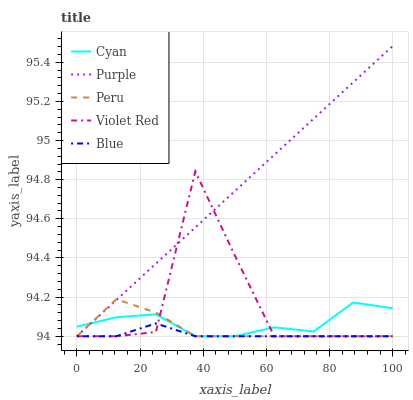Does Blue have the minimum area under the curve?
Answer yes or no. Yes. Does Purple have the maximum area under the curve?
Answer yes or no. Yes. Does Cyan have the minimum area under the curve?
Answer yes or no. No. Does Cyan have the maximum area under the curve?
Answer yes or no. No. Is Purple the smoothest?
Answer yes or no. Yes. Is Violet Red the roughest?
Answer yes or no. Yes. Is Cyan the smoothest?
Answer yes or no. No. Is Cyan the roughest?
Answer yes or no. No. Does Purple have the lowest value?
Answer yes or no. Yes. Does Purple have the highest value?
Answer yes or no. Yes. Does Cyan have the highest value?
Answer yes or no. No. Does Purple intersect Violet Red?
Answer yes or no. Yes. Is Purple less than Violet Red?
Answer yes or no. No. Is Purple greater than Violet Red?
Answer yes or no. No. 